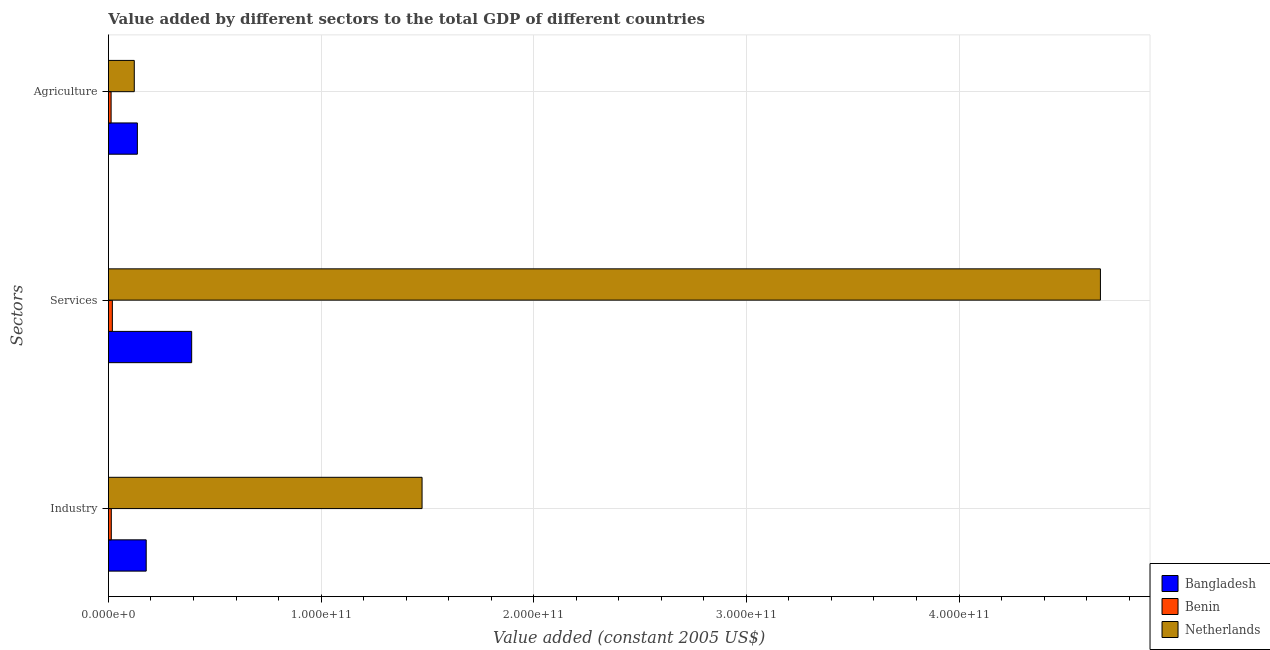Are the number of bars per tick equal to the number of legend labels?
Your answer should be compact. Yes. How many bars are there on the 3rd tick from the top?
Provide a succinct answer. 3. How many bars are there on the 3rd tick from the bottom?
Provide a succinct answer. 3. What is the label of the 3rd group of bars from the top?
Give a very brief answer. Industry. What is the value added by industrial sector in Bangladesh?
Your answer should be very brief. 1.78e+1. Across all countries, what is the maximum value added by agricultural sector?
Offer a very short reply. 1.36e+1. Across all countries, what is the minimum value added by agricultural sector?
Ensure brevity in your answer.  1.26e+09. In which country was the value added by services maximum?
Make the answer very short. Netherlands. In which country was the value added by agricultural sector minimum?
Provide a succinct answer. Benin. What is the total value added by services in the graph?
Provide a succinct answer. 5.07e+11. What is the difference between the value added by services in Netherlands and that in Benin?
Your answer should be compact. 4.65e+11. What is the difference between the value added by services in Bangladesh and the value added by agricultural sector in Benin?
Ensure brevity in your answer.  3.79e+1. What is the average value added by agricultural sector per country?
Your response must be concise. 9.01e+09. What is the difference between the value added by industrial sector and value added by agricultural sector in Netherlands?
Provide a succinct answer. 1.35e+11. What is the ratio of the value added by agricultural sector in Netherlands to that in Benin?
Keep it short and to the point. 9.62. What is the difference between the highest and the second highest value added by industrial sector?
Your response must be concise. 1.30e+11. What is the difference between the highest and the lowest value added by industrial sector?
Your answer should be very brief. 1.46e+11. In how many countries, is the value added by services greater than the average value added by services taken over all countries?
Your answer should be compact. 1. Is the sum of the value added by services in Benin and Netherlands greater than the maximum value added by agricultural sector across all countries?
Offer a very short reply. Yes. What does the 3rd bar from the bottom in Agriculture represents?
Your answer should be very brief. Netherlands. Are all the bars in the graph horizontal?
Provide a succinct answer. Yes. How many countries are there in the graph?
Provide a short and direct response. 3. What is the difference between two consecutive major ticks on the X-axis?
Your answer should be compact. 1.00e+11. Does the graph contain any zero values?
Offer a terse response. No. Does the graph contain grids?
Provide a succinct answer. Yes. How are the legend labels stacked?
Your answer should be compact. Vertical. What is the title of the graph?
Give a very brief answer. Value added by different sectors to the total GDP of different countries. Does "Thailand" appear as one of the legend labels in the graph?
Offer a terse response. No. What is the label or title of the X-axis?
Provide a succinct answer. Value added (constant 2005 US$). What is the label or title of the Y-axis?
Ensure brevity in your answer.  Sectors. What is the Value added (constant 2005 US$) in Bangladesh in Industry?
Provide a short and direct response. 1.78e+1. What is the Value added (constant 2005 US$) in Benin in Industry?
Keep it short and to the point. 1.35e+09. What is the Value added (constant 2005 US$) of Netherlands in Industry?
Offer a terse response. 1.47e+11. What is the Value added (constant 2005 US$) in Bangladesh in Services?
Make the answer very short. 3.91e+1. What is the Value added (constant 2005 US$) in Benin in Services?
Offer a very short reply. 1.85e+09. What is the Value added (constant 2005 US$) in Netherlands in Services?
Make the answer very short. 4.66e+11. What is the Value added (constant 2005 US$) of Bangladesh in Agriculture?
Give a very brief answer. 1.36e+1. What is the Value added (constant 2005 US$) in Benin in Agriculture?
Your answer should be very brief. 1.26e+09. What is the Value added (constant 2005 US$) of Netherlands in Agriculture?
Your answer should be very brief. 1.22e+1. Across all Sectors, what is the maximum Value added (constant 2005 US$) of Bangladesh?
Offer a very short reply. 3.91e+1. Across all Sectors, what is the maximum Value added (constant 2005 US$) of Benin?
Ensure brevity in your answer.  1.85e+09. Across all Sectors, what is the maximum Value added (constant 2005 US$) of Netherlands?
Offer a terse response. 4.66e+11. Across all Sectors, what is the minimum Value added (constant 2005 US$) in Bangladesh?
Keep it short and to the point. 1.36e+1. Across all Sectors, what is the minimum Value added (constant 2005 US$) of Benin?
Your answer should be very brief. 1.26e+09. Across all Sectors, what is the minimum Value added (constant 2005 US$) of Netherlands?
Give a very brief answer. 1.22e+1. What is the total Value added (constant 2005 US$) of Bangladesh in the graph?
Make the answer very short. 7.05e+1. What is the total Value added (constant 2005 US$) of Benin in the graph?
Your answer should be very brief. 4.46e+09. What is the total Value added (constant 2005 US$) of Netherlands in the graph?
Make the answer very short. 6.26e+11. What is the difference between the Value added (constant 2005 US$) in Bangladesh in Industry and that in Services?
Give a very brief answer. -2.14e+1. What is the difference between the Value added (constant 2005 US$) in Benin in Industry and that in Services?
Give a very brief answer. -4.99e+08. What is the difference between the Value added (constant 2005 US$) in Netherlands in Industry and that in Services?
Offer a very short reply. -3.19e+11. What is the difference between the Value added (constant 2005 US$) of Bangladesh in Industry and that in Agriculture?
Keep it short and to the point. 4.15e+09. What is the difference between the Value added (constant 2005 US$) of Benin in Industry and that in Agriculture?
Keep it short and to the point. 8.43e+07. What is the difference between the Value added (constant 2005 US$) in Netherlands in Industry and that in Agriculture?
Offer a terse response. 1.35e+11. What is the difference between the Value added (constant 2005 US$) in Bangladesh in Services and that in Agriculture?
Offer a very short reply. 2.55e+1. What is the difference between the Value added (constant 2005 US$) of Benin in Services and that in Agriculture?
Provide a succinct answer. 5.83e+08. What is the difference between the Value added (constant 2005 US$) in Netherlands in Services and that in Agriculture?
Provide a succinct answer. 4.54e+11. What is the difference between the Value added (constant 2005 US$) in Bangladesh in Industry and the Value added (constant 2005 US$) in Benin in Services?
Offer a very short reply. 1.59e+1. What is the difference between the Value added (constant 2005 US$) in Bangladesh in Industry and the Value added (constant 2005 US$) in Netherlands in Services?
Give a very brief answer. -4.49e+11. What is the difference between the Value added (constant 2005 US$) of Benin in Industry and the Value added (constant 2005 US$) of Netherlands in Services?
Provide a short and direct response. -4.65e+11. What is the difference between the Value added (constant 2005 US$) in Bangladesh in Industry and the Value added (constant 2005 US$) in Benin in Agriculture?
Offer a terse response. 1.65e+1. What is the difference between the Value added (constant 2005 US$) in Bangladesh in Industry and the Value added (constant 2005 US$) in Netherlands in Agriculture?
Provide a succinct answer. 5.61e+09. What is the difference between the Value added (constant 2005 US$) in Benin in Industry and the Value added (constant 2005 US$) in Netherlands in Agriculture?
Give a very brief answer. -1.08e+1. What is the difference between the Value added (constant 2005 US$) in Bangladesh in Services and the Value added (constant 2005 US$) in Benin in Agriculture?
Offer a very short reply. 3.79e+1. What is the difference between the Value added (constant 2005 US$) in Bangladesh in Services and the Value added (constant 2005 US$) in Netherlands in Agriculture?
Your answer should be very brief. 2.70e+1. What is the difference between the Value added (constant 2005 US$) in Benin in Services and the Value added (constant 2005 US$) in Netherlands in Agriculture?
Keep it short and to the point. -1.03e+1. What is the average Value added (constant 2005 US$) of Bangladesh per Sectors?
Provide a succinct answer. 2.35e+1. What is the average Value added (constant 2005 US$) of Benin per Sectors?
Your response must be concise. 1.49e+09. What is the average Value added (constant 2005 US$) in Netherlands per Sectors?
Provide a short and direct response. 2.09e+11. What is the difference between the Value added (constant 2005 US$) in Bangladesh and Value added (constant 2005 US$) in Benin in Industry?
Your answer should be very brief. 1.64e+1. What is the difference between the Value added (constant 2005 US$) of Bangladesh and Value added (constant 2005 US$) of Netherlands in Industry?
Your response must be concise. -1.30e+11. What is the difference between the Value added (constant 2005 US$) in Benin and Value added (constant 2005 US$) in Netherlands in Industry?
Your answer should be very brief. -1.46e+11. What is the difference between the Value added (constant 2005 US$) of Bangladesh and Value added (constant 2005 US$) of Benin in Services?
Your answer should be very brief. 3.73e+1. What is the difference between the Value added (constant 2005 US$) in Bangladesh and Value added (constant 2005 US$) in Netherlands in Services?
Make the answer very short. -4.27e+11. What is the difference between the Value added (constant 2005 US$) in Benin and Value added (constant 2005 US$) in Netherlands in Services?
Ensure brevity in your answer.  -4.65e+11. What is the difference between the Value added (constant 2005 US$) in Bangladesh and Value added (constant 2005 US$) in Benin in Agriculture?
Offer a very short reply. 1.23e+1. What is the difference between the Value added (constant 2005 US$) in Bangladesh and Value added (constant 2005 US$) in Netherlands in Agriculture?
Provide a succinct answer. 1.45e+09. What is the difference between the Value added (constant 2005 US$) of Benin and Value added (constant 2005 US$) of Netherlands in Agriculture?
Give a very brief answer. -1.09e+1. What is the ratio of the Value added (constant 2005 US$) of Bangladesh in Industry to that in Services?
Your answer should be very brief. 0.45. What is the ratio of the Value added (constant 2005 US$) of Benin in Industry to that in Services?
Your answer should be very brief. 0.73. What is the ratio of the Value added (constant 2005 US$) of Netherlands in Industry to that in Services?
Provide a succinct answer. 0.32. What is the ratio of the Value added (constant 2005 US$) in Bangladesh in Industry to that in Agriculture?
Make the answer very short. 1.31. What is the ratio of the Value added (constant 2005 US$) in Benin in Industry to that in Agriculture?
Offer a very short reply. 1.07. What is the ratio of the Value added (constant 2005 US$) of Netherlands in Industry to that in Agriculture?
Provide a succinct answer. 12.13. What is the ratio of the Value added (constant 2005 US$) in Bangladesh in Services to that in Agriculture?
Keep it short and to the point. 2.88. What is the ratio of the Value added (constant 2005 US$) of Benin in Services to that in Agriculture?
Your answer should be compact. 1.46. What is the ratio of the Value added (constant 2005 US$) in Netherlands in Services to that in Agriculture?
Your response must be concise. 38.37. What is the difference between the highest and the second highest Value added (constant 2005 US$) of Bangladesh?
Keep it short and to the point. 2.14e+1. What is the difference between the highest and the second highest Value added (constant 2005 US$) of Benin?
Give a very brief answer. 4.99e+08. What is the difference between the highest and the second highest Value added (constant 2005 US$) of Netherlands?
Offer a terse response. 3.19e+11. What is the difference between the highest and the lowest Value added (constant 2005 US$) in Bangladesh?
Ensure brevity in your answer.  2.55e+1. What is the difference between the highest and the lowest Value added (constant 2005 US$) in Benin?
Provide a succinct answer. 5.83e+08. What is the difference between the highest and the lowest Value added (constant 2005 US$) of Netherlands?
Make the answer very short. 4.54e+11. 